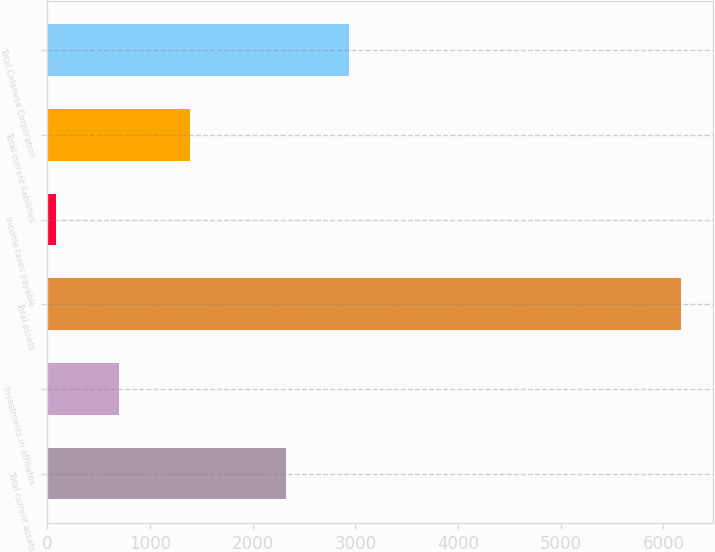<chart> <loc_0><loc_0><loc_500><loc_500><bar_chart><fcel>Total current assets<fcel>Investments in affiliates<fcel>Total assets<fcel>Income taxes payable<fcel>Total current liabilities<fcel>Total Celanese Corporation<nl><fcel>2328<fcel>694.8<fcel>6174<fcel>86<fcel>1384<fcel>2936.8<nl></chart> 